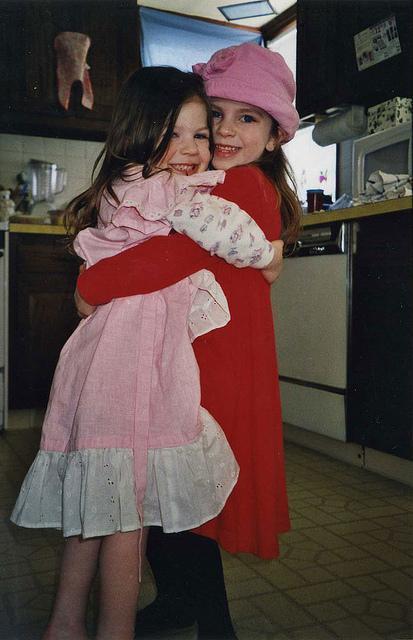How many girls are wearing hats?
Give a very brief answer. 1. How many people can be seen?
Give a very brief answer. 2. 